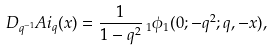<formula> <loc_0><loc_0><loc_500><loc_500>D _ { q ^ { - 1 } } A i _ { q } ( x ) = \frac { 1 } { 1 - q ^ { 2 } } \, _ { 1 } \phi _ { 1 } ( 0 ; - q ^ { 2 } ; q , - x ) ,</formula> 